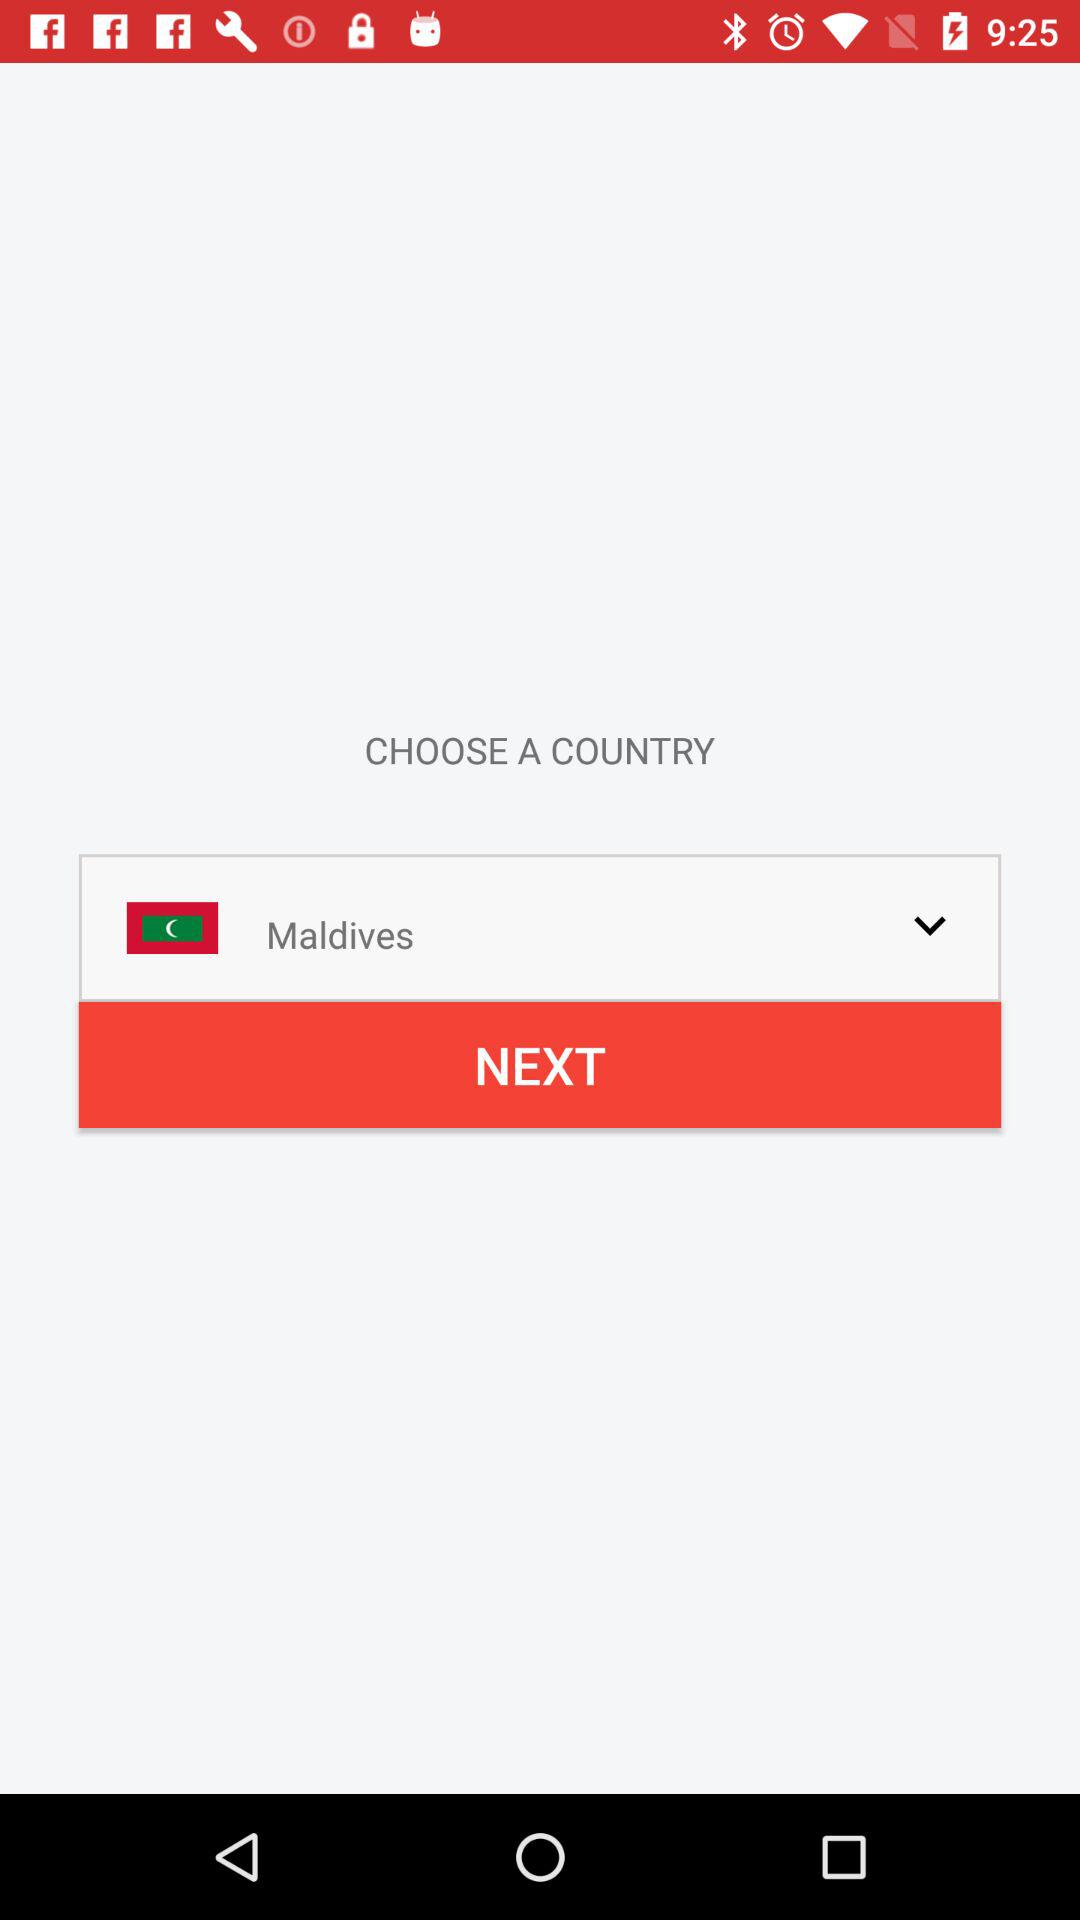What is the given country's name? The given country's name is the Maldives. 